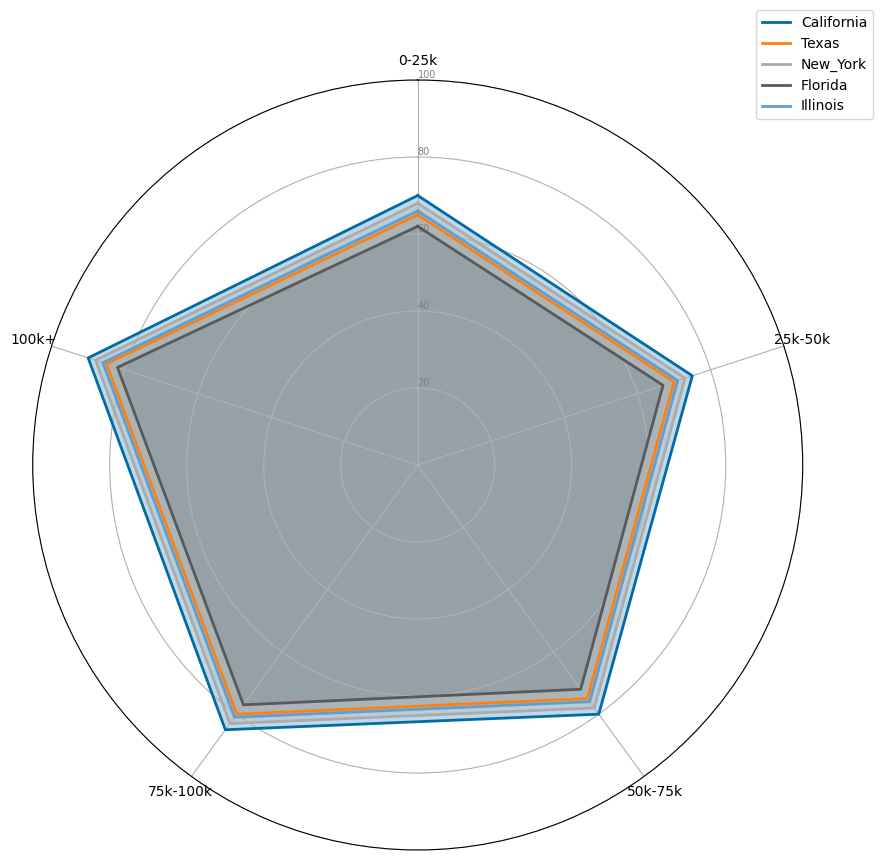Which state has the highest Access to Healthcare Score for the 0-25k income bracket? The highest Access to Healthcare Score for the 0-25k income bracket can be found by visually comparing the values for each state around the point labeled "0-25k." California has the highest score at 70.
Answer: California Which state shows the greatest range of Access to Healthcare Scores across all income brackets? The range is determined by the difference between the maximum and minimum scores for each state. Visually comparing the states, California has scores ranging from 70 to 90, indicating a 20-point range.
Answer: California Compare the Access to Healthcare Scores for Texas and Illinois in the 100k+ income bracket. Which state scores higher? Look at the points labeled "100k+" for both Texas and Illinois. Texas has a score of 85, while Illinois has a score of 86.
Answer: Illinois On average, do higher income brackets have better access to healthcare across all states? Observing the trend, it's visible that for every state, the Access to Healthcare Score increases as the income bracket increases. Visually confirming this trend for all states suggests that higher income brackets do have better access to healthcare.
Answer: Yes Which state has the lowest score in the 50k-75k income bracket, and what is the score? To find the state with the lowest score in the 50k-75k income bracket, visually compare the values for each state around the "50k-75k" point. Florida has the lowest score at 72.
Answer: Florida How does the Access to Healthcare Score for New York in the 25k-50k income bracket compare to the average score of other states in the same bracket? New York has a score of 73 in the 25k-50k bracket. The scores for other states in the same bracket are 75 (California), 70 (Texas), 67 (Florida), and 71 (Illinois). The average score of the other states is (75+70+67+71)/4 = 70.75, which is lower than New York's score of 73.
Answer: Higher What is the average Access to Healthcare Score for Illinois across all income brackets, and how does it compare to Texas' average? Illinois scores are 66, 71, 76, 81, 86 across the brackets. The average score for Illinois is (66+71+76+81+86)/5 = 76. Texas scores are 65, 70, 75, 80, 85, averaging to (65+70+75+80+85)/5 = 75.2. Comparing the two averages, Illinois has a slightly higher average score.
Answer: Illinois 76, Texas 75.2 Compare California's Access to Healthcare Scores in the 0-25k and 100k+ income brackets. What is the difference? California’s Access to Healthcare Score in the 0-25k bracket is 70, while in the 100k+ bracket it is 90. The difference is 90 - 70 = 20.
Answer: 20 Visually, which state appears to have the most balanced (least variability) Access to Healthcare across all income brackets? A balanced score would show relatively minor changes across income brackets. Observing the radar chart, New York appears to have smooth transitions and closer scores across all income brackets ranging from 68 to 88, making it more balanced compared to other states with steeper changes.
Answer: New York What is the median Access to Healthcare Score for all states in the 75k-100k income bracket? Scores in the 75k-100k bracket are 85 (California), 80 (Texas), 83 (New York), 77 (Florida), and 81 (Illinois). Arranging these scores in ascending order gives 77, 80, 81, 83, 85. The median score is the middle value, which is 81.
Answer: 81 